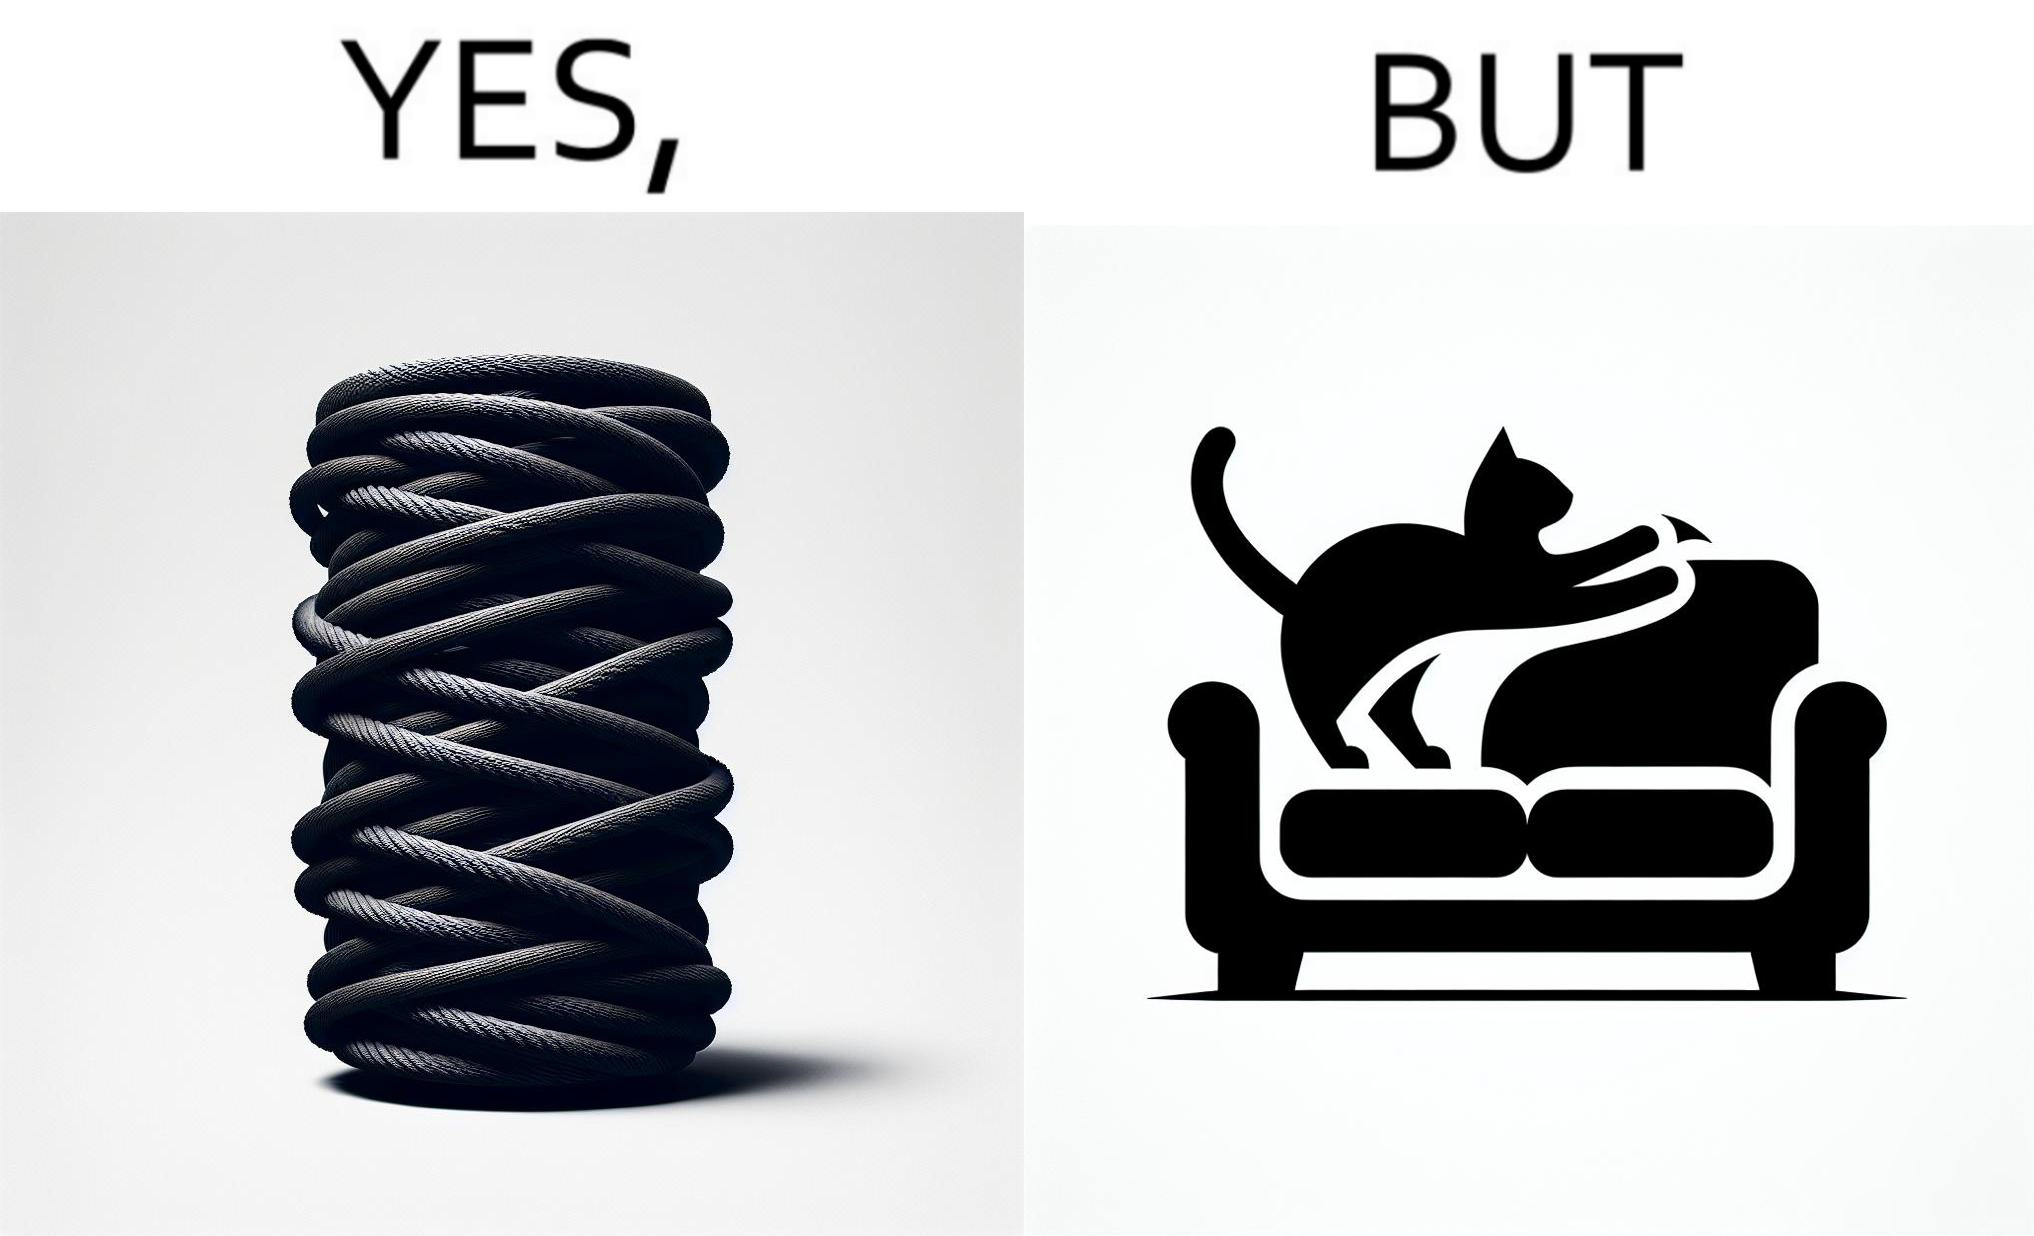Why is this image considered satirical? The image is ironic, because in the first image a toy, purposed for the cat to play with is shown but in the second image the cat is comfortably enjoying  to play on the sides of sofa 